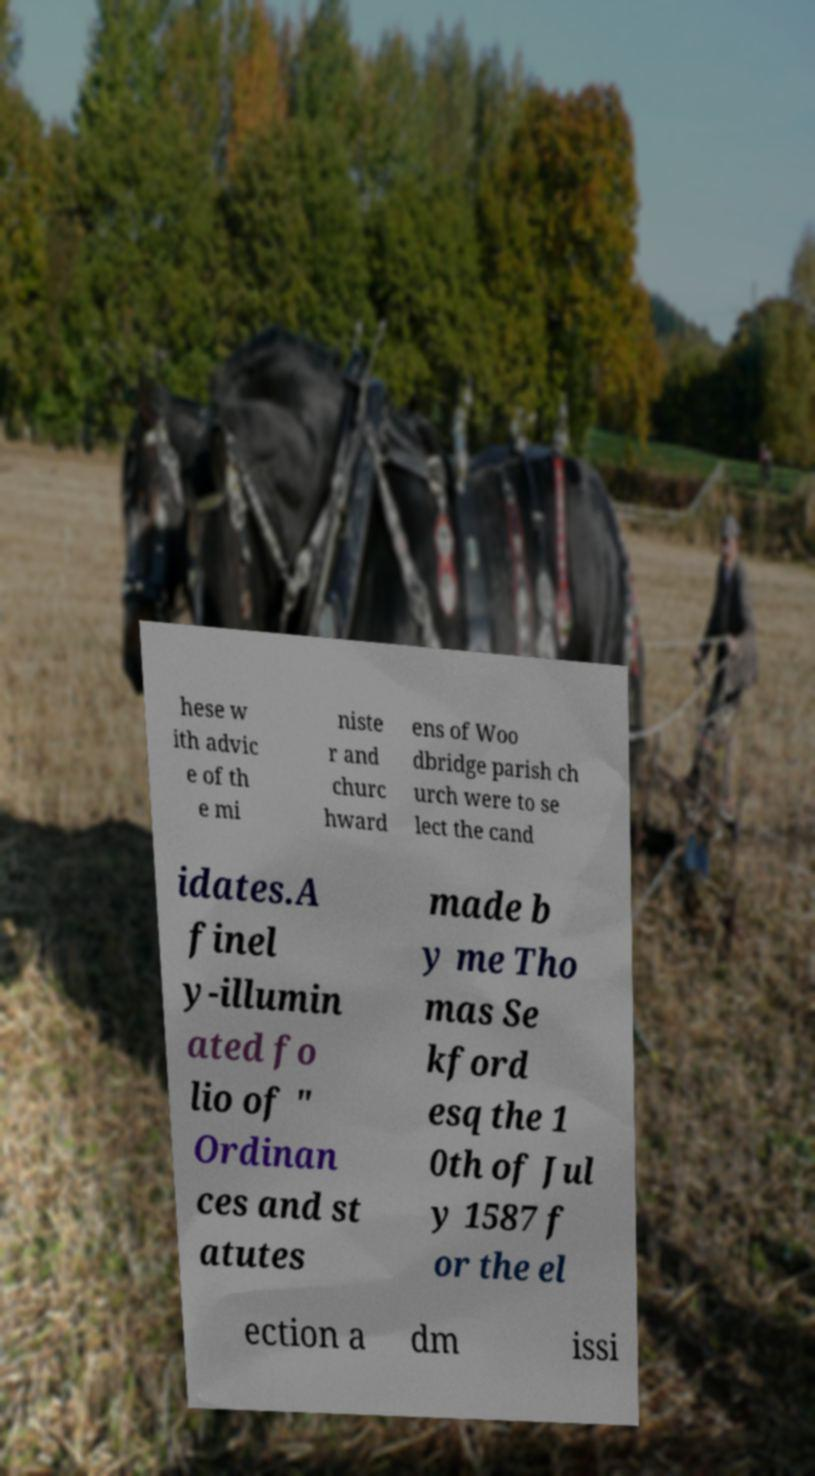Could you assist in decoding the text presented in this image and type it out clearly? hese w ith advic e of th e mi niste r and churc hward ens of Woo dbridge parish ch urch were to se lect the cand idates.A finel y-illumin ated fo lio of " Ordinan ces and st atutes made b y me Tho mas Se kford esq the 1 0th of Jul y 1587 f or the el ection a dm issi 